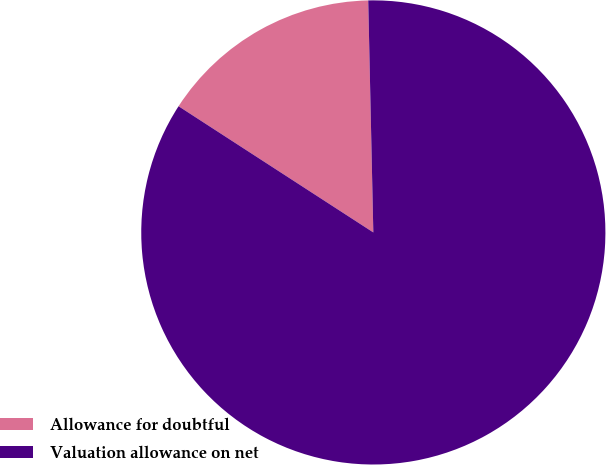<chart> <loc_0><loc_0><loc_500><loc_500><pie_chart><fcel>Allowance for doubtful<fcel>Valuation allowance on net<nl><fcel>15.5%<fcel>84.5%<nl></chart> 